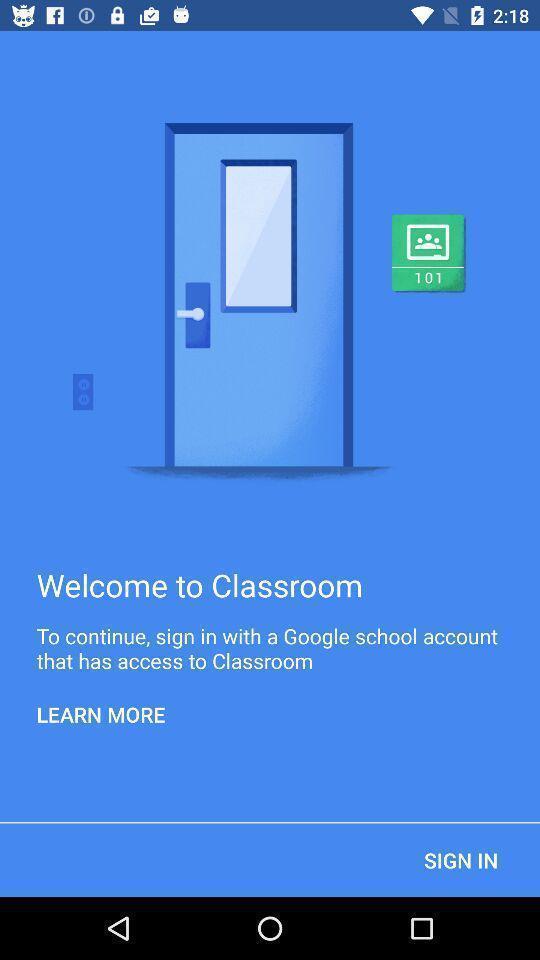What is the overall content of this screenshot? Welcome page. 